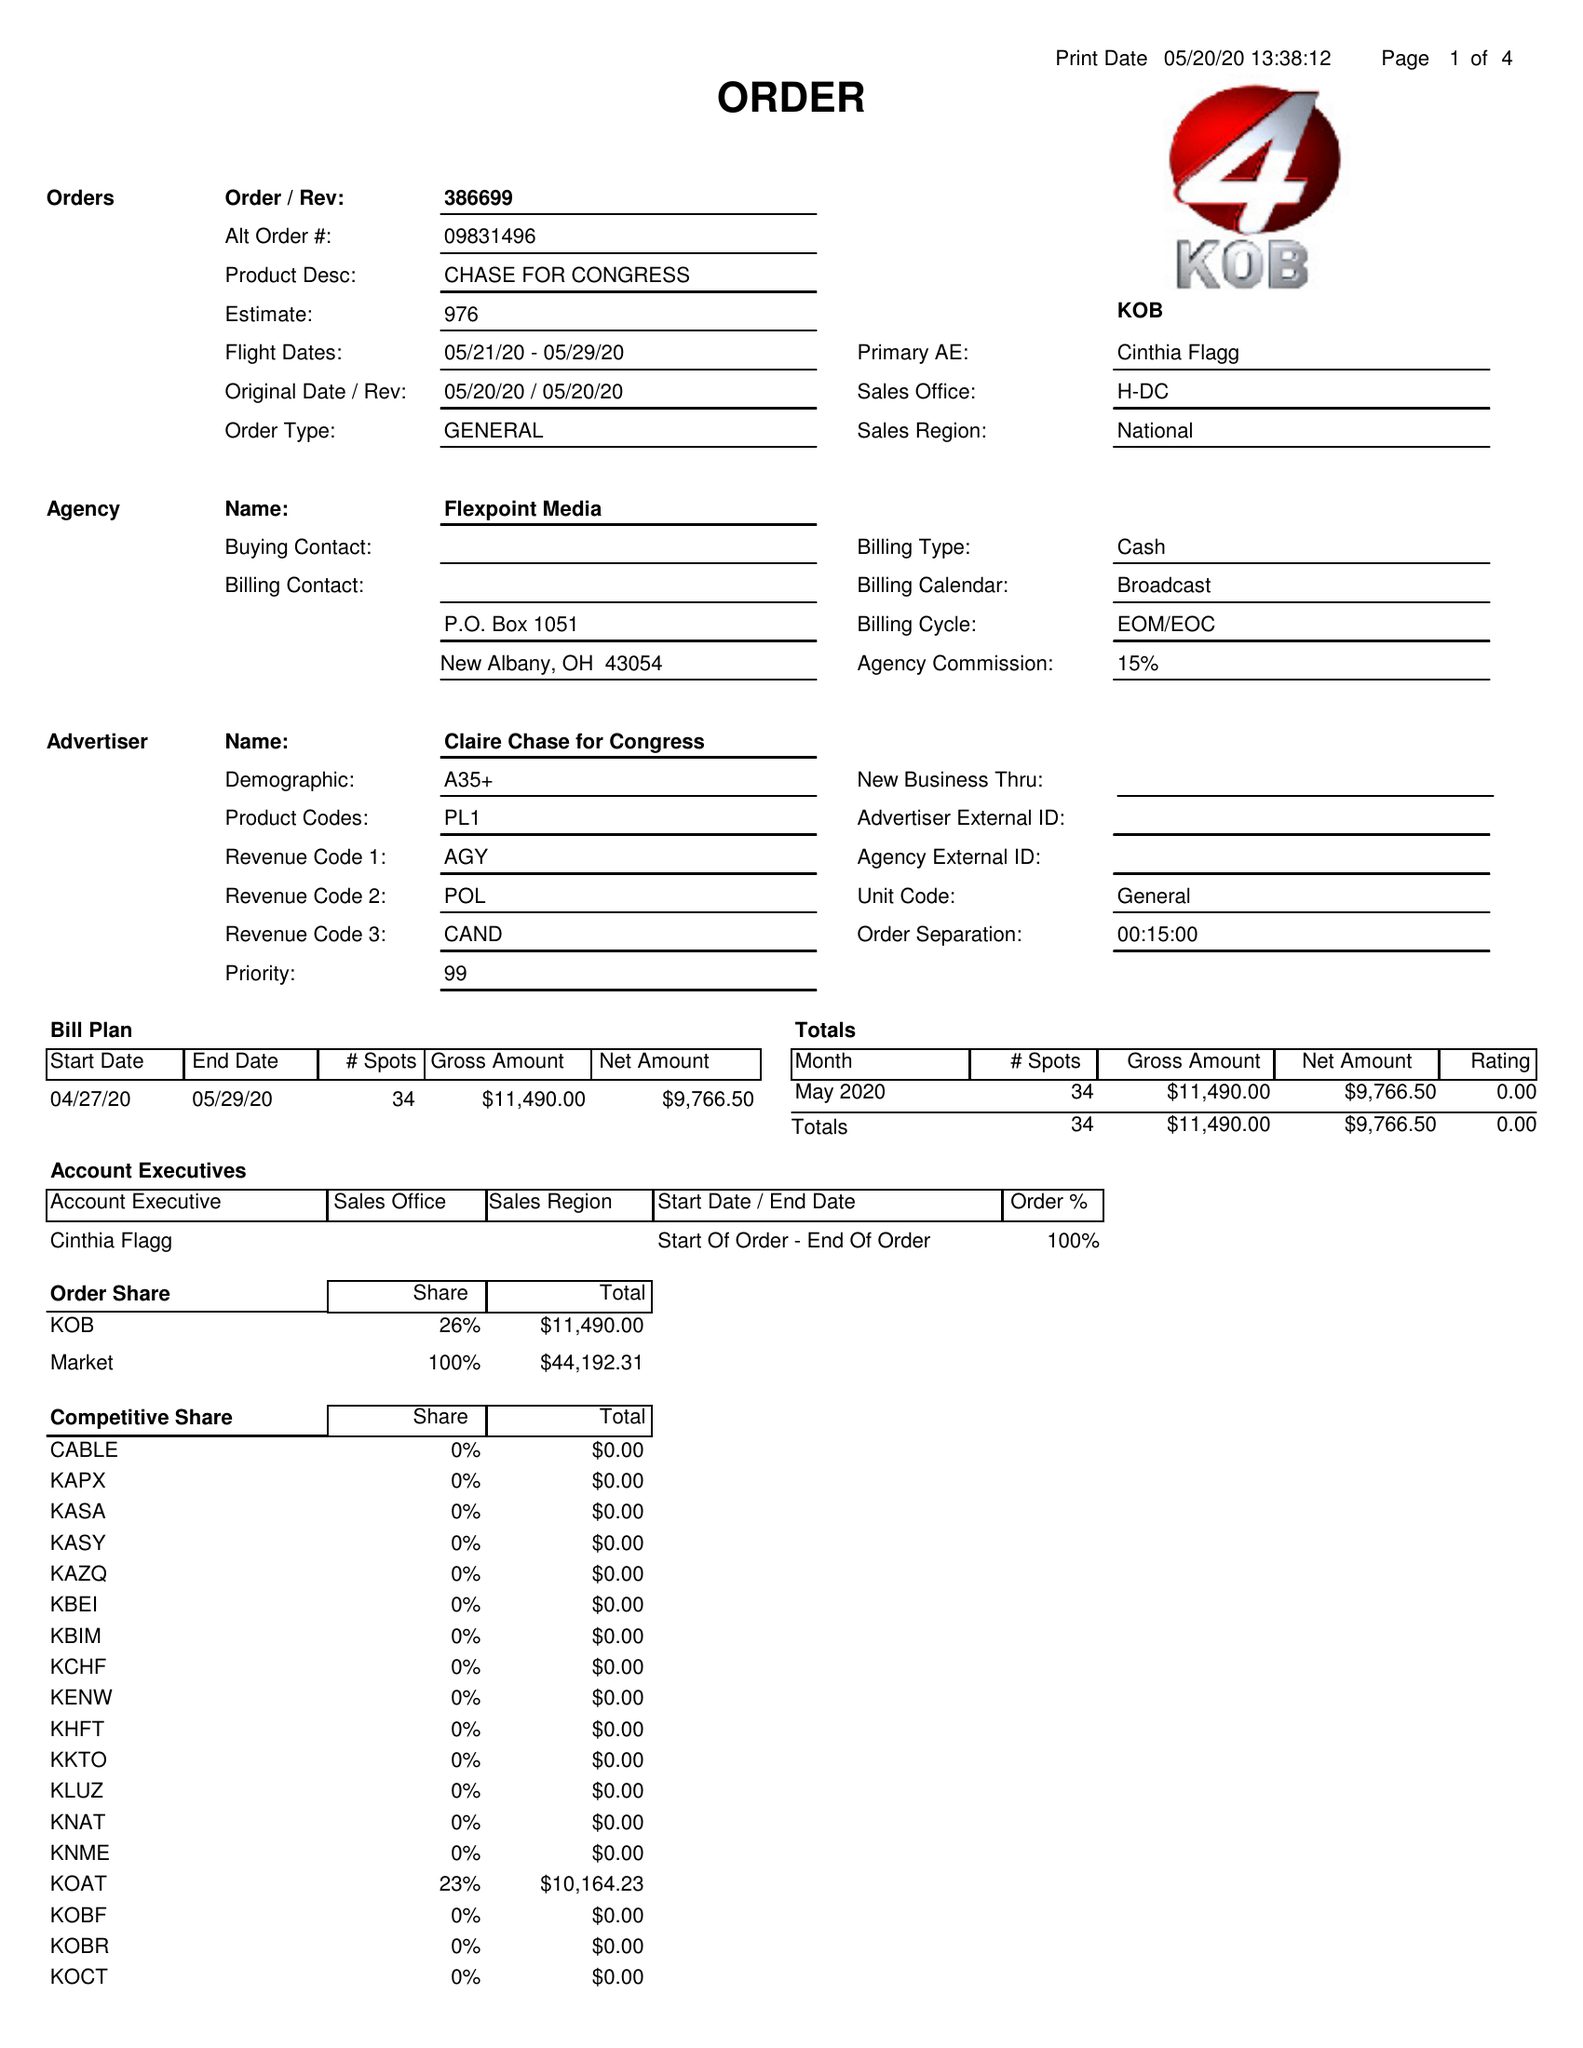What is the value for the flight_from?
Answer the question using a single word or phrase. 05/21/20 